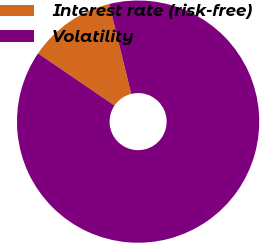Convert chart to OTSL. <chart><loc_0><loc_0><loc_500><loc_500><pie_chart><fcel>Interest rate (risk-free)<fcel>Volatility<nl><fcel>11.64%<fcel>88.36%<nl></chart> 